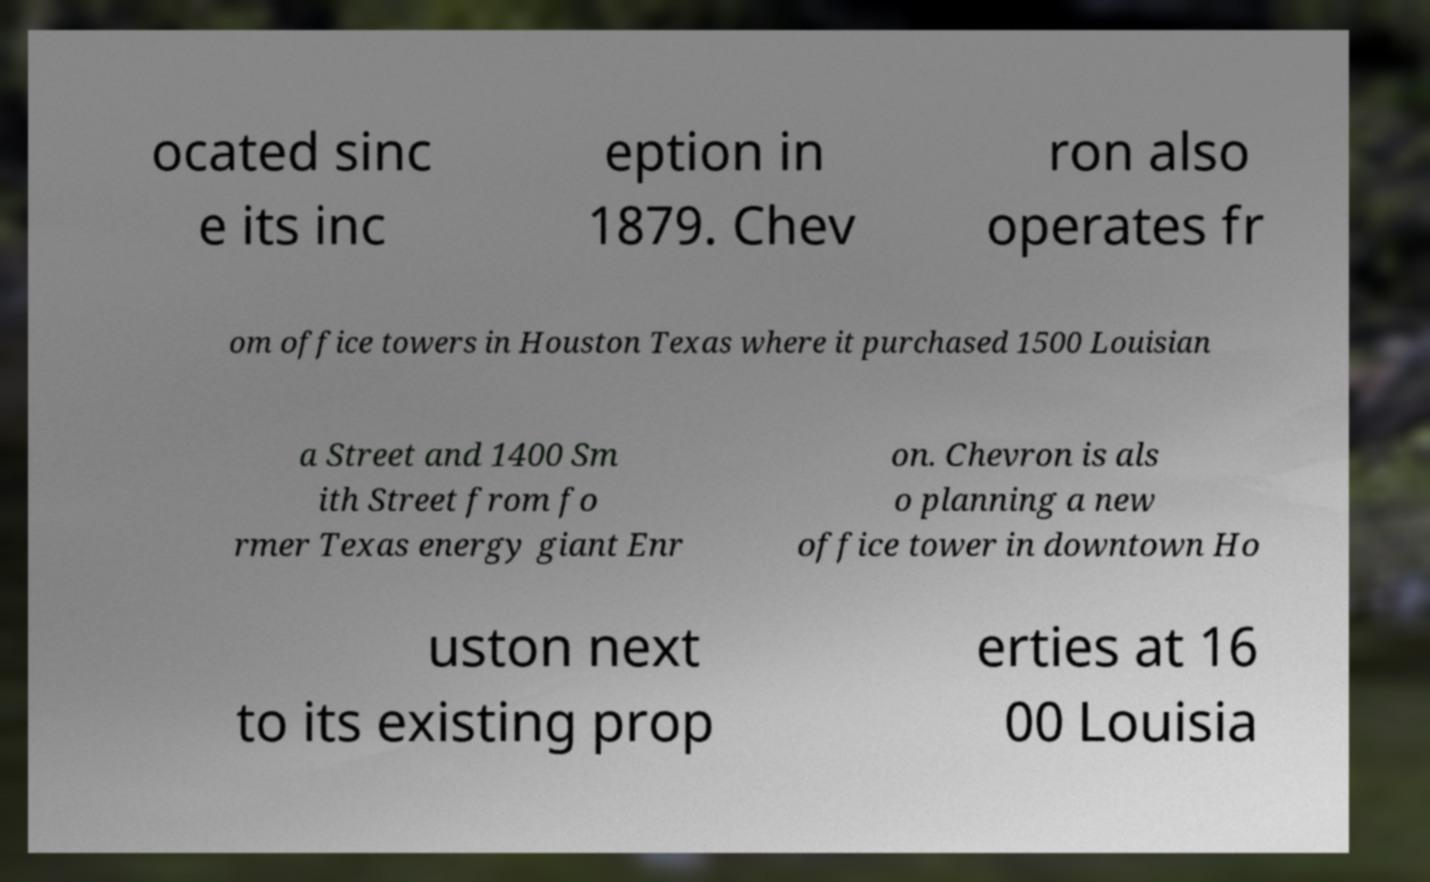Please identify and transcribe the text found in this image. ocated sinc e its inc eption in 1879. Chev ron also operates fr om office towers in Houston Texas where it purchased 1500 Louisian a Street and 1400 Sm ith Street from fo rmer Texas energy giant Enr on. Chevron is als o planning a new office tower in downtown Ho uston next to its existing prop erties at 16 00 Louisia 